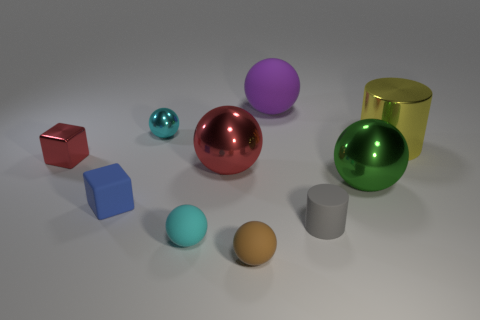The thing that is the same color as the tiny metal sphere is what size?
Give a very brief answer. Small. There is another tiny metallic object that is the same shape as the green shiny object; what color is it?
Provide a succinct answer. Cyan. Does the red metallic ball have the same size as the blue object?
Give a very brief answer. No. What is the material of the cylinder that is in front of the yellow shiny cylinder?
Your answer should be very brief. Rubber. What number of other things are there of the same shape as the big green metal thing?
Your answer should be very brief. 5. Is the purple object the same shape as the small cyan rubber thing?
Give a very brief answer. Yes. There is a tiny red object; are there any big metal objects in front of it?
Your answer should be very brief. Yes. What number of things are tiny cylinders or rubber blocks?
Your response must be concise. 2. How many other things are there of the same size as the cyan metallic thing?
Offer a very short reply. 5. What number of small objects are both behind the gray rubber object and in front of the green metal sphere?
Provide a short and direct response. 1. 